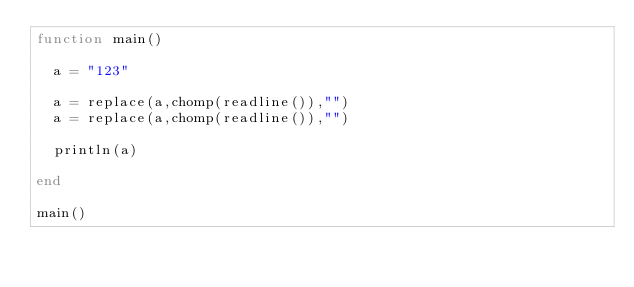<code> <loc_0><loc_0><loc_500><loc_500><_Julia_>function main()
  
  a = "123"
  
  a = replace(a,chomp(readline()),"")
  a = replace(a,chomp(readline()),"")
  
  println(a)
  
end

main()</code> 